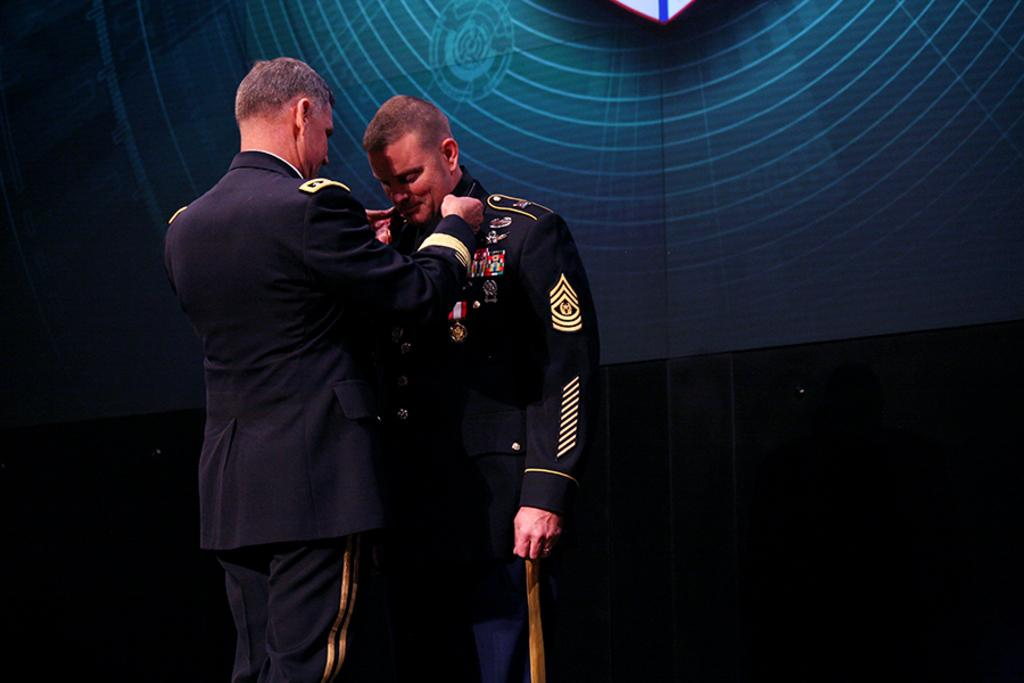How many people are in the image? There are two persons in the image. What are the two persons doing in the image? The two persons are standing. What are the two persons wearing in the image? The two persons are wearing blue color uniforms. What can be seen in the background of the image? There is a wall in the background of the image. What type of verse can be heard being recited by one of the persons in the image? There is no indication in the image that any verse is being recited, as the focus is on the two persons standing and wearing blue color uniforms. 